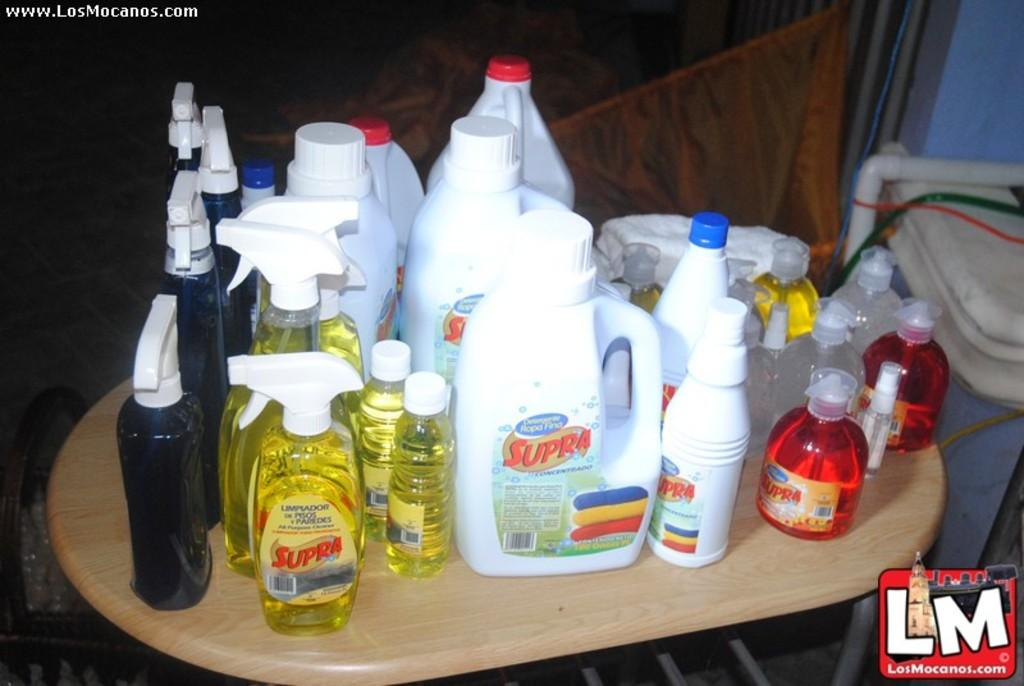Provide a one-sentence caption for the provided image. A table full of cleaners that have the word Supra written on it. 